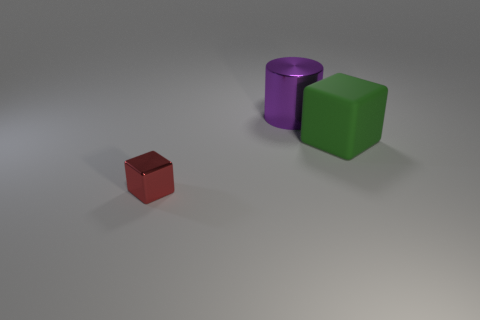Add 3 large purple metallic cylinders. How many objects exist? 6 Subtract all cylinders. How many objects are left? 2 Add 1 cylinders. How many cylinders are left? 2 Add 1 small red balls. How many small red balls exist? 1 Subtract 0 purple balls. How many objects are left? 3 Subtract all shiny cylinders. Subtract all yellow cylinders. How many objects are left? 2 